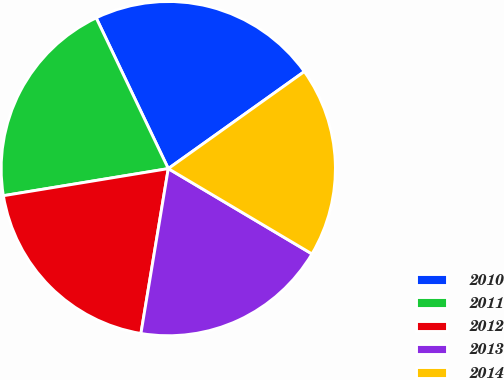Convert chart to OTSL. <chart><loc_0><loc_0><loc_500><loc_500><pie_chart><fcel>2010<fcel>2011<fcel>2012<fcel>2013<fcel>2014<nl><fcel>22.24%<fcel>20.49%<fcel>19.79%<fcel>19.09%<fcel>18.39%<nl></chart> 